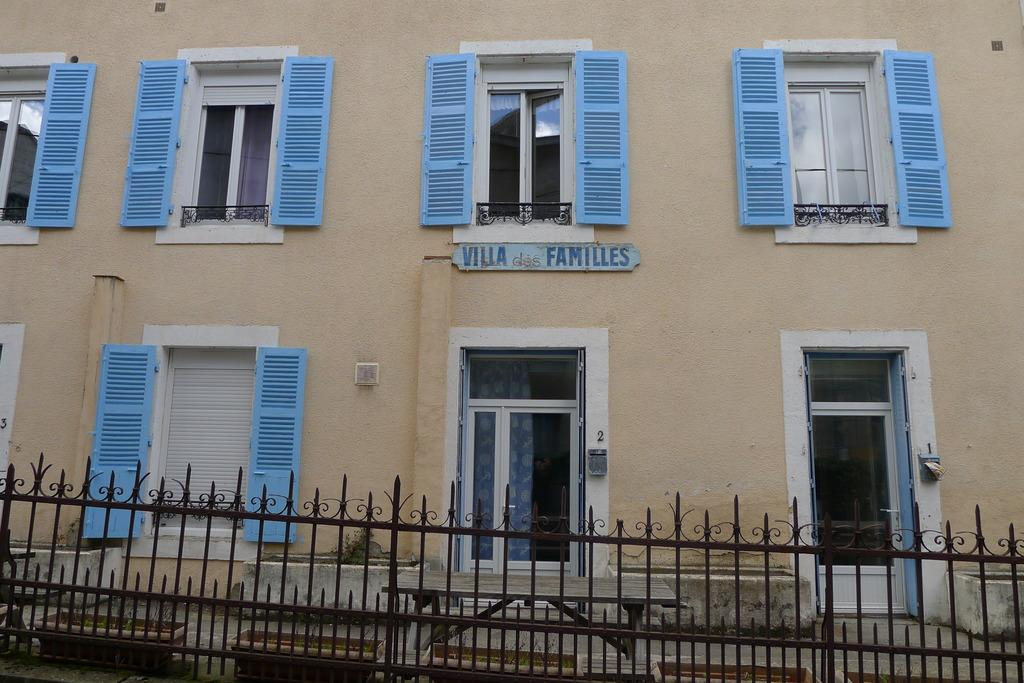What type of structure can be seen in the image? There are iron grills in the image. What other objects are present in the image? There are flower pots, glass objects, windows, text, and numbers visible in the image. Can you describe the additional objects on the building? There are additional objects on the building, but their specific details are not mentioned in the provided facts. Where is the tent located in the image? There is no tent present in the image. What type of crate can be seen in the image? There is no crate present in the image. 